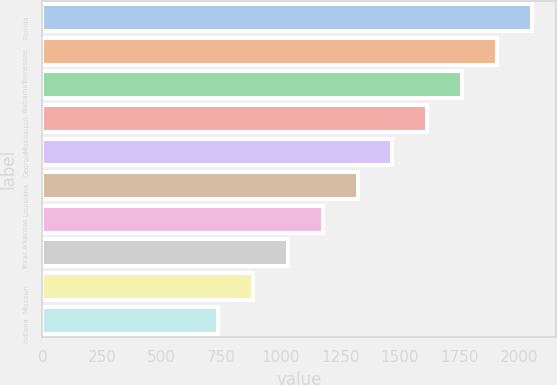Convert chart to OTSL. <chart><loc_0><loc_0><loc_500><loc_500><bar_chart><fcel>Florida<fcel>Tennessee<fcel>Alabama<fcel>Mississippi<fcel>Georgia<fcel>Louisiana<fcel>Arkansas<fcel>Texas<fcel>Missouri<fcel>Indiana<nl><fcel>2054.2<fcel>1907.9<fcel>1761.6<fcel>1615.3<fcel>1469<fcel>1322.7<fcel>1176.4<fcel>1030.1<fcel>883.8<fcel>737.5<nl></chart> 